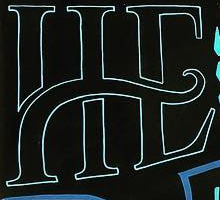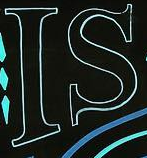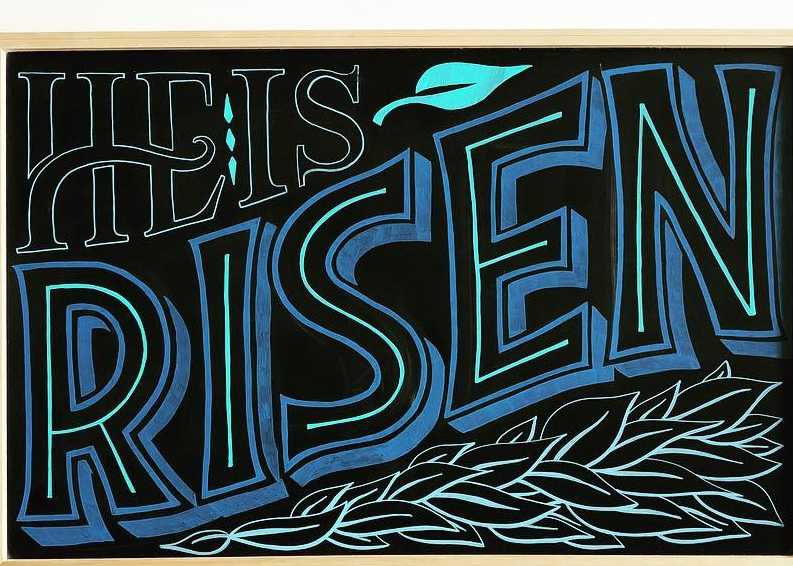Identify the words shown in these images in order, separated by a semicolon. HE; IS; RISEN 